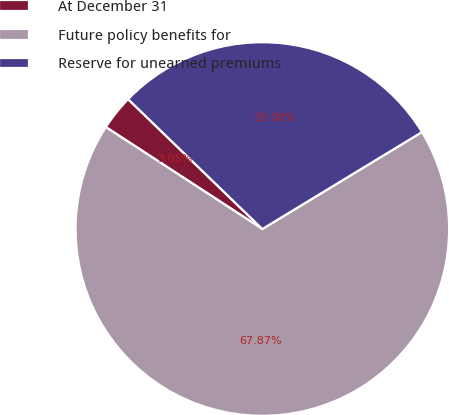<chart> <loc_0><loc_0><loc_500><loc_500><pie_chart><fcel>At December 31<fcel>Future policy benefits for<fcel>Reserve for unearned premiums<nl><fcel>3.05%<fcel>67.88%<fcel>29.08%<nl></chart> 